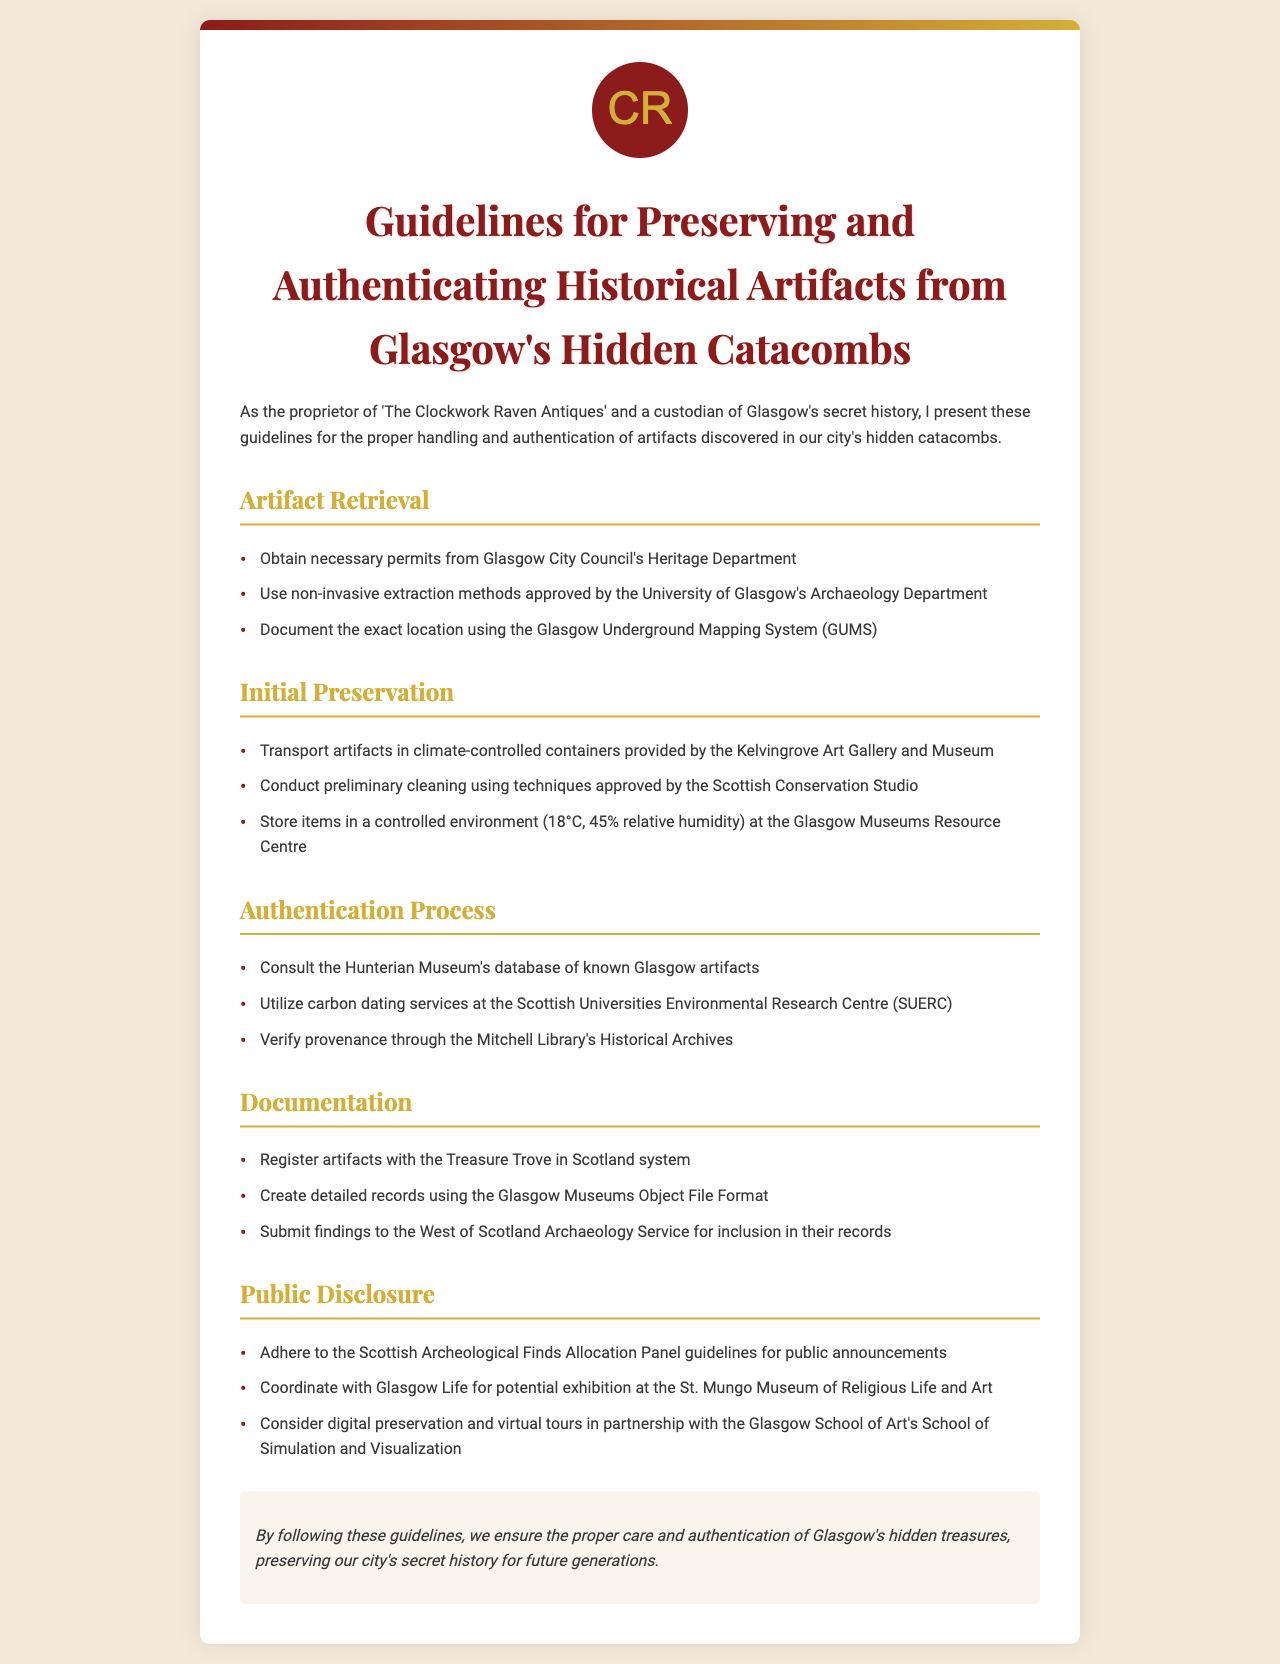What is the title of the document? The title is the heading found at the top of the document, summarizing its content.
Answer: Guidelines for Preserving and Authenticating Historical Artifacts from Glasgow's Hidden Catacombs Who must give permits for artifact retrieval? The document states that permits should be obtained from a specific authority listed within.
Answer: Glasgow City Council's Heritage Department What temperature should artifacts be stored at? The document specifies a controlled temperature for artifact storage under Initial Preservation.
Answer: 18°C Which museum's database should be consulted for artifact authentication? The document lists a specific museum that maintains a relevant database for verification.
Answer: Hunterian Museum What is the relative humidity percentage for storing artifacts? The document indicates a specific percentage for preserving artifacts to ensure their longevity.
Answer: 45% relative humidity How should artifacts be transported? The document provides guidance on the means of transport for the artifacts to maintain their condition.
Answer: Climate-controlled containers Which organization should findings be submitted to? The document mentions an organization that receives findings for record-keeping purposes.
Answer: West of Scotland Archaeology Service What should be utilized for carbon dating? The document specifies a particular service available for conducting carbon dating.
Answer: Scottish Universities Environmental Research Centre Where should public announcements adhere to guidelines from? The document highlights an authority concerning public disclosures and announcements related to archaeological finds.
Answer: Scottish Archaeological Finds Allocation Panel 